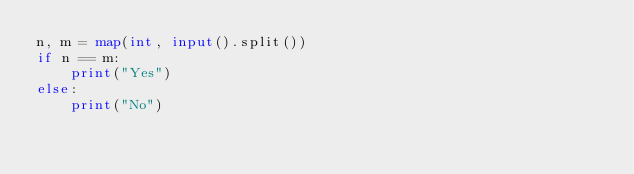Convert code to text. <code><loc_0><loc_0><loc_500><loc_500><_Python_>n, m = map(int, input().split())
if n == m:
    print("Yes")
else:
    print("No")
</code> 